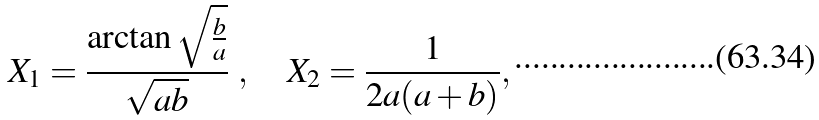<formula> <loc_0><loc_0><loc_500><loc_500>X _ { 1 } = \frac { \arctan \sqrt { \frac { b } { a } } } { \sqrt { a b } } \ , \quad X _ { 2 } = \frac { 1 } { 2 a ( a + b ) } ,</formula> 